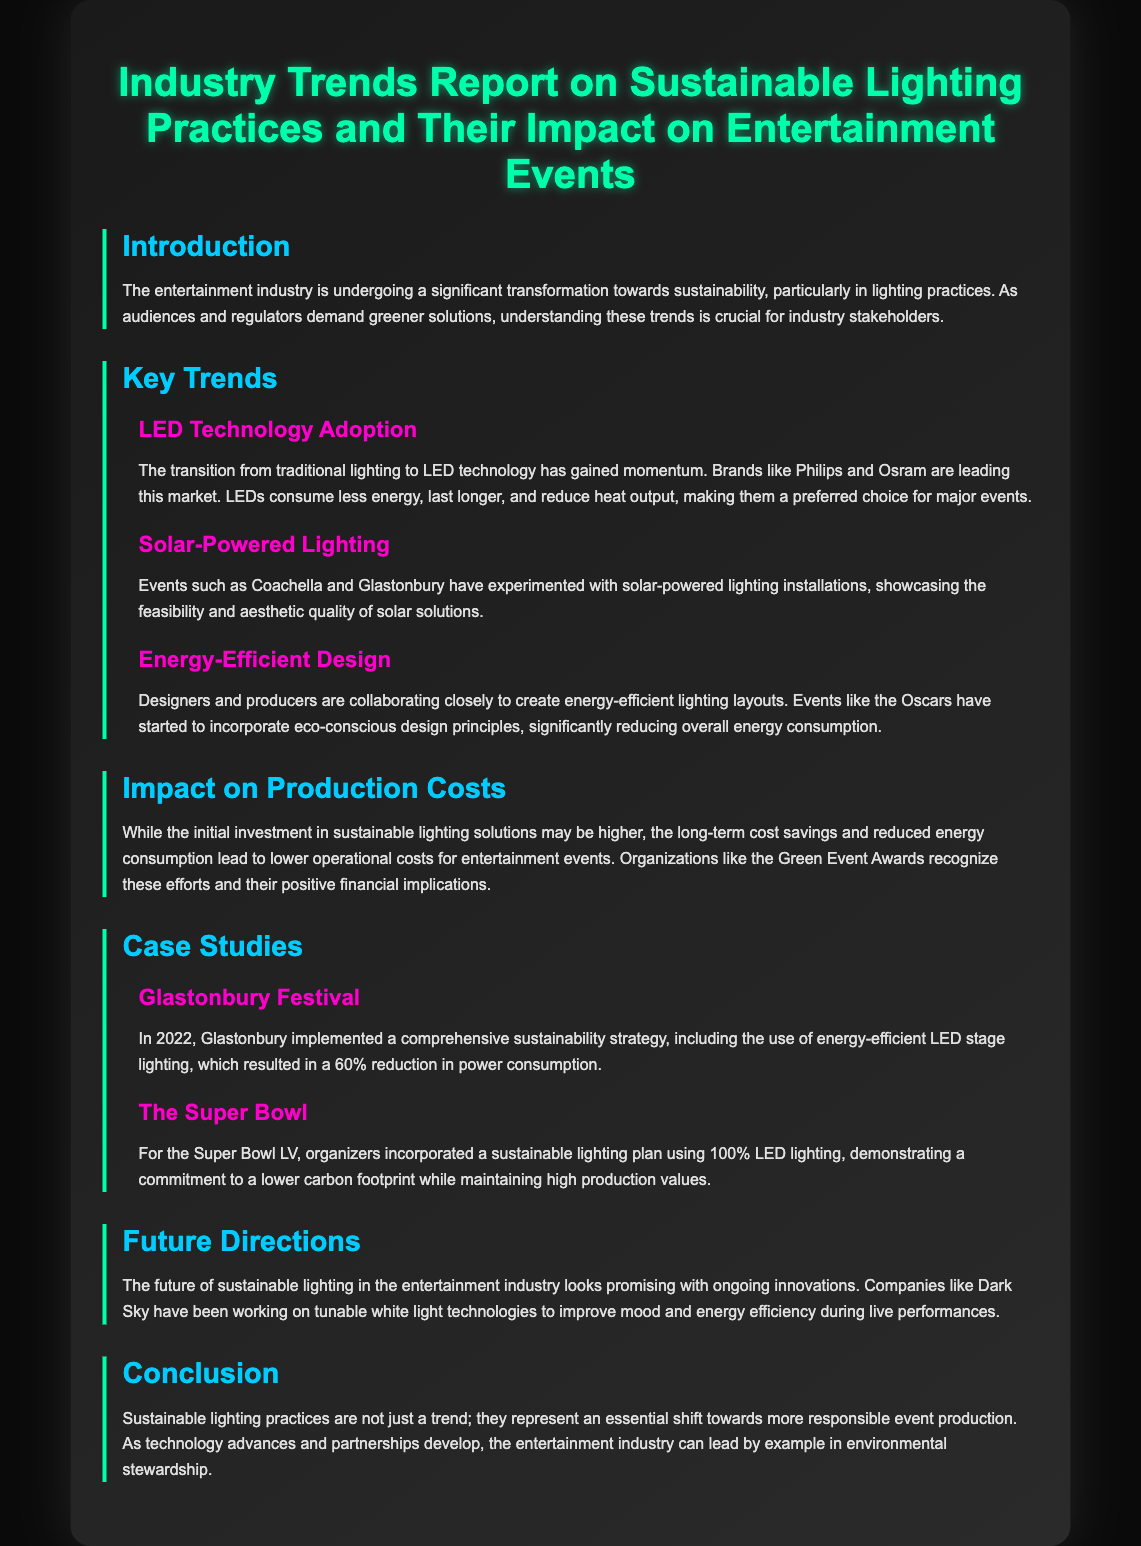What are the two key companies leading the LED market? The document mentions Philips and Osram as the leading companies in LED technology.
Answer: Philips and Osram What was the power consumption reduction percentage at Glastonbury Festival? In the case study of Glastonbury Festival, it reported a 60% reduction in power consumption due to sustainable practices.
Answer: 60% What type of lighting was used for the Super Bowl LV? The Super Bowl LV incorporated a lighting plan that utilized 100% LED lighting.
Answer: 100% LED lighting Which lighting practice is highlighted as a trend in the entertainment industry? The report highlights LED technology adoption as a significant trend in sustainable lighting practices for entertainment events.
Answer: LED technology adoption What is a major benefit of sustainable lighting practices according to the document? The document states that sustainable lighting practices lead to lower operational costs for entertainment events over time.
Answer: Lower operational costs 